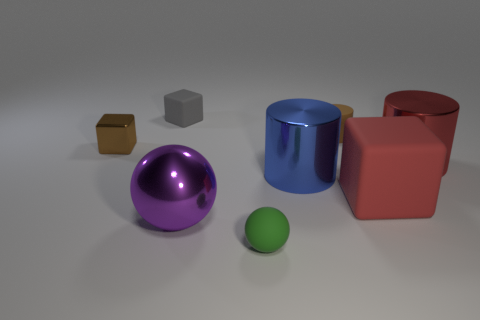What shape is the tiny thing that is on the right side of the small green rubber sphere?
Make the answer very short. Cylinder. There is a large rubber object; is its shape the same as the brown thing that is to the right of the small brown shiny cube?
Provide a short and direct response. No. How big is the object that is both on the right side of the tiny rubber cylinder and in front of the large blue cylinder?
Give a very brief answer. Large. What color is the shiny object that is behind the big metallic sphere and left of the green sphere?
Offer a very short reply. Brown. Is there any other thing that has the same material as the large red block?
Your answer should be compact. Yes. Is the number of tiny cylinders that are to the left of the small brown metal thing less than the number of small brown matte cylinders in front of the big red metallic object?
Give a very brief answer. No. Is there anything else that is the same color as the large matte cube?
Your response must be concise. Yes. The blue thing is what shape?
Keep it short and to the point. Cylinder. There is another small object that is the same material as the purple object; what color is it?
Your answer should be very brief. Brown. Is the number of small metallic blocks greater than the number of large metallic things?
Your answer should be very brief. No. 